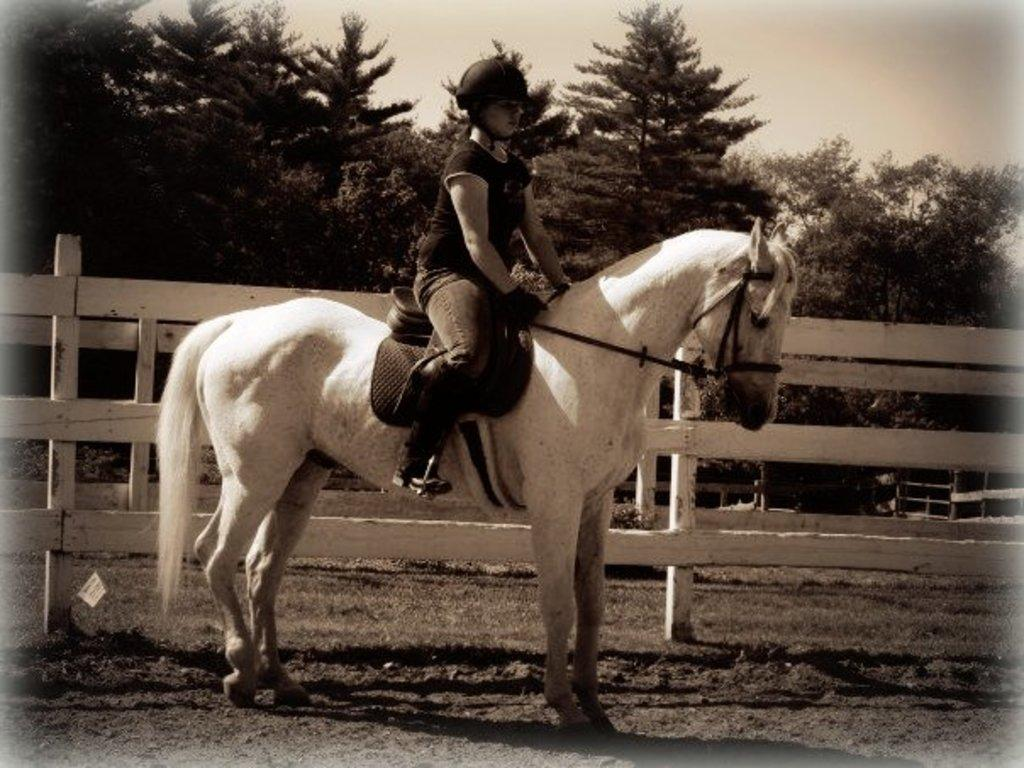What is the person in the image riding? The person is sitting on a white horse. What can be seen in the background of the image? There are trees and the sky visible in the background. What type of holiday is the person celebrating in the image? There is no indication of a holiday in the image; it simply shows a person sitting on a horse with trees and the sky in the background. 